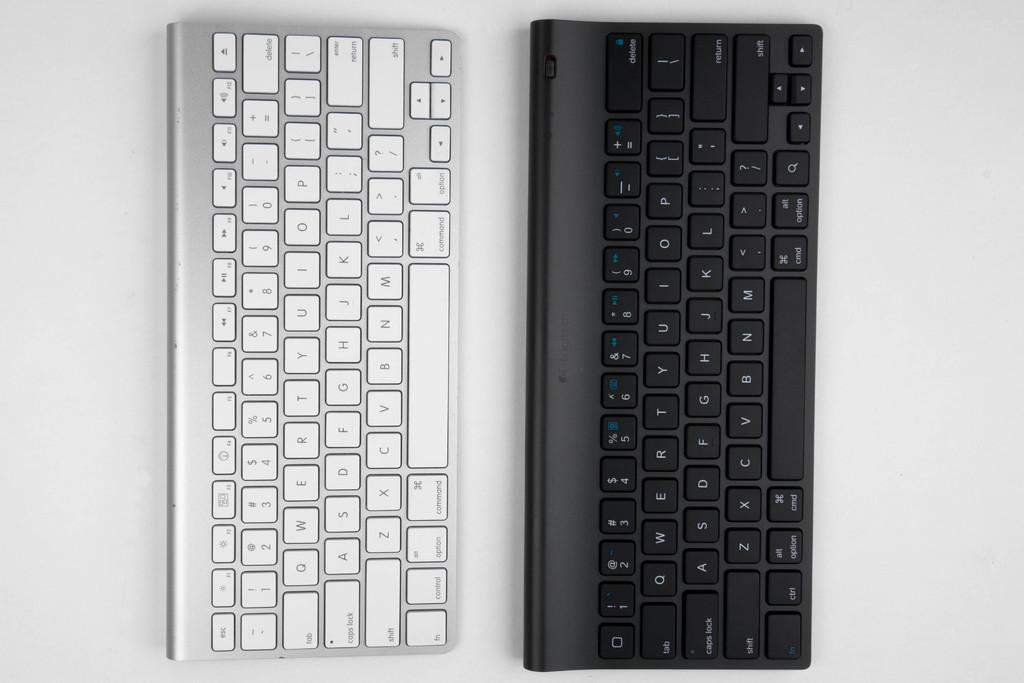<image>
Create a compact narrative representing the image presented. a silver keyboard is laying beside a black keyboard; both with the basic letters and enter function keys 